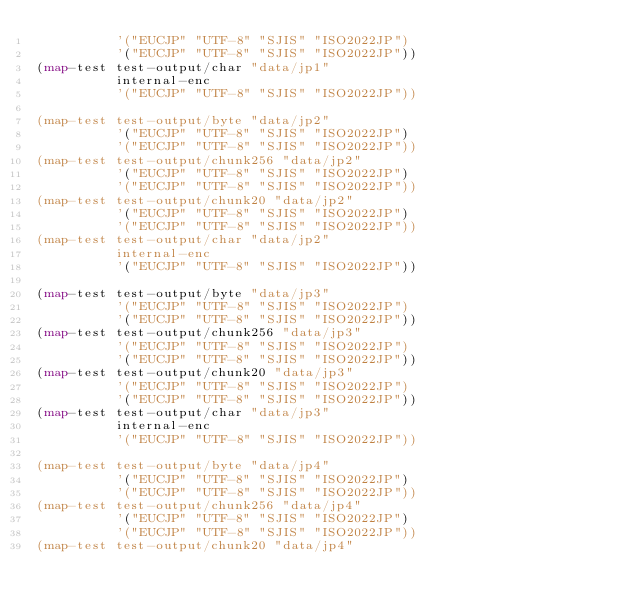Convert code to text. <code><loc_0><loc_0><loc_500><loc_500><_Scheme_>          '("EUCJP" "UTF-8" "SJIS" "ISO2022JP")
          '("EUCJP" "UTF-8" "SJIS" "ISO2022JP"))
(map-test test-output/char "data/jp1"
          internal-enc
          '("EUCJP" "UTF-8" "SJIS" "ISO2022JP"))

(map-test test-output/byte "data/jp2"
          '("EUCJP" "UTF-8" "SJIS" "ISO2022JP")
          '("EUCJP" "UTF-8" "SJIS" "ISO2022JP"))
(map-test test-output/chunk256 "data/jp2"
          '("EUCJP" "UTF-8" "SJIS" "ISO2022JP")
          '("EUCJP" "UTF-8" "SJIS" "ISO2022JP"))
(map-test test-output/chunk20 "data/jp2"
          '("EUCJP" "UTF-8" "SJIS" "ISO2022JP")
          '("EUCJP" "UTF-8" "SJIS" "ISO2022JP"))
(map-test test-output/char "data/jp2"
          internal-enc
          '("EUCJP" "UTF-8" "SJIS" "ISO2022JP"))

(map-test test-output/byte "data/jp3"
          '("EUCJP" "UTF-8" "SJIS" "ISO2022JP")
          '("EUCJP" "UTF-8" "SJIS" "ISO2022JP"))
(map-test test-output/chunk256 "data/jp3"
          '("EUCJP" "UTF-8" "SJIS" "ISO2022JP")
          '("EUCJP" "UTF-8" "SJIS" "ISO2022JP"))
(map-test test-output/chunk20 "data/jp3"
          '("EUCJP" "UTF-8" "SJIS" "ISO2022JP")
          '("EUCJP" "UTF-8" "SJIS" "ISO2022JP"))
(map-test test-output/char "data/jp3"
          internal-enc
          '("EUCJP" "UTF-8" "SJIS" "ISO2022JP"))

(map-test test-output/byte "data/jp4"
          '("EUCJP" "UTF-8" "SJIS" "ISO2022JP")
          '("EUCJP" "UTF-8" "SJIS" "ISO2022JP"))
(map-test test-output/chunk256 "data/jp4"
          '("EUCJP" "UTF-8" "SJIS" "ISO2022JP")
          '("EUCJP" "UTF-8" "SJIS" "ISO2022JP"))
(map-test test-output/chunk20 "data/jp4"</code> 